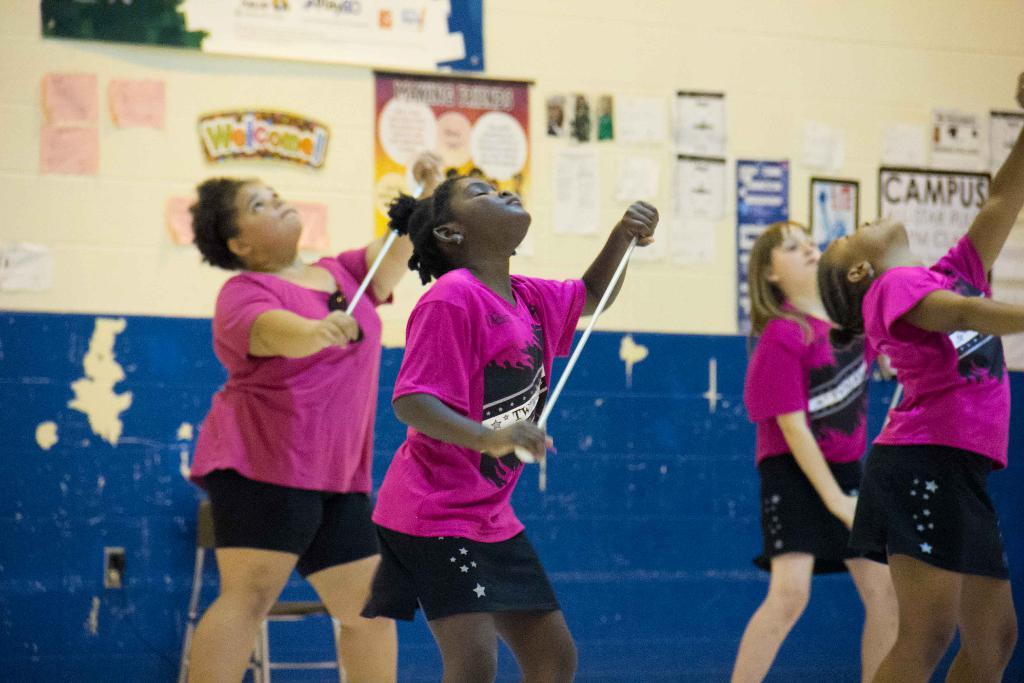What can be seen in the image? There are girls standing in the image. What are the girls holding in their hands? The girls are holding ropes in their hands. What can be seen on the wall in the background? There are posters on the wall in the background. What type of minister is present in the image? There is no minister present in the image. How many times do the girls bite the ropes in the image? The girls do not bite the ropes in the image; they are holding them. 